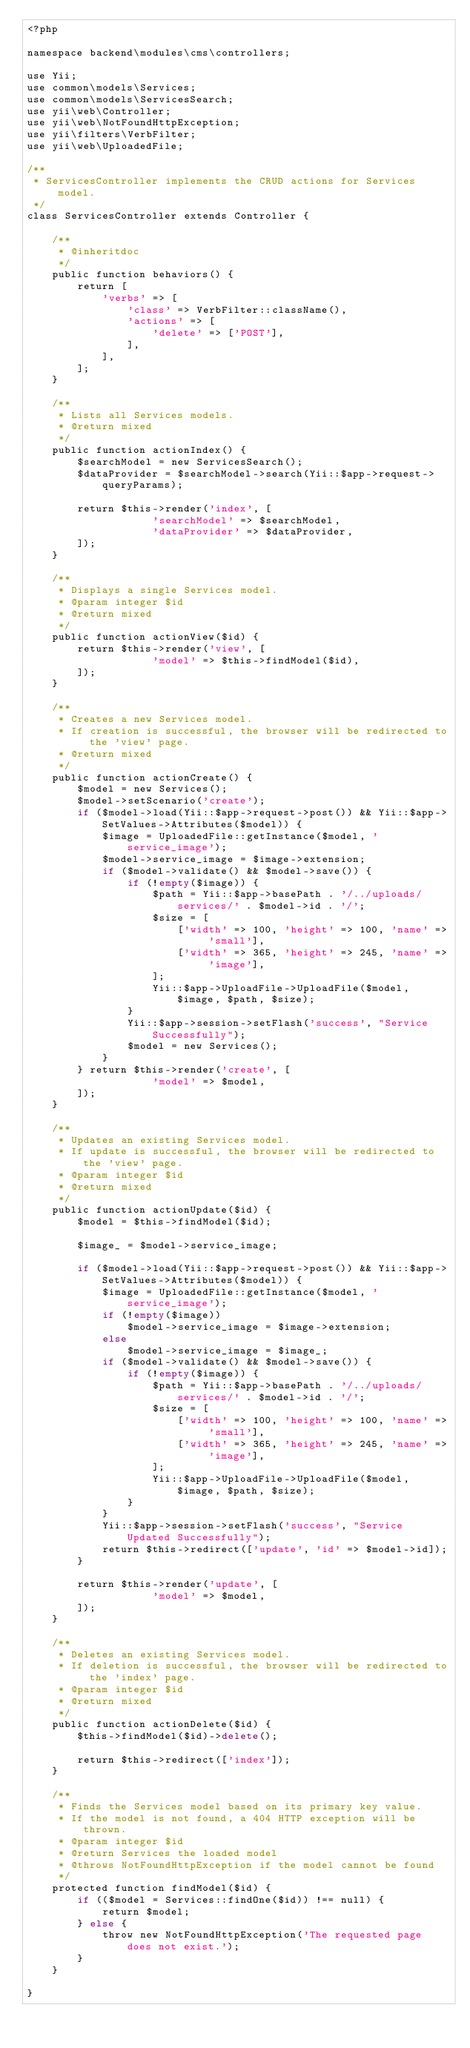Convert code to text. <code><loc_0><loc_0><loc_500><loc_500><_PHP_><?php

namespace backend\modules\cms\controllers;

use Yii;
use common\models\Services;
use common\models\ServicesSearch;
use yii\web\Controller;
use yii\web\NotFoundHttpException;
use yii\filters\VerbFilter;
use yii\web\UploadedFile;

/**
 * ServicesController implements the CRUD actions for Services model.
 */
class ServicesController extends Controller {

    /**
     * @inheritdoc
     */
    public function behaviors() {
        return [
            'verbs' => [
                'class' => VerbFilter::className(),
                'actions' => [
                    'delete' => ['POST'],
                ],
            ],
        ];
    }

    /**
     * Lists all Services models.
     * @return mixed
     */
    public function actionIndex() {
        $searchModel = new ServicesSearch();
        $dataProvider = $searchModel->search(Yii::$app->request->queryParams);

        return $this->render('index', [
                    'searchModel' => $searchModel,
                    'dataProvider' => $dataProvider,
        ]);
    }

    /**
     * Displays a single Services model.
     * @param integer $id
     * @return mixed
     */
    public function actionView($id) {
        return $this->render('view', [
                    'model' => $this->findModel($id),
        ]);
    }

    /**
     * Creates a new Services model.
     * If creation is successful, the browser will be redirected to the 'view' page.
     * @return mixed
     */
    public function actionCreate() {
        $model = new Services();
        $model->setScenario('create');
        if ($model->load(Yii::$app->request->post()) && Yii::$app->SetValues->Attributes($model)) {
            $image = UploadedFile::getInstance($model, 'service_image');
            $model->service_image = $image->extension;
            if ($model->validate() && $model->save()) {
                if (!empty($image)) {
                    $path = Yii::$app->basePath . '/../uploads/services/' . $model->id . '/';
                    $size = [
                        ['width' => 100, 'height' => 100, 'name' => 'small'],
                        ['width' => 365, 'height' => 245, 'name' => 'image'],
                    ];
                    Yii::$app->UploadFile->UploadFile($model, $image, $path, $size);
                }
                Yii::$app->session->setFlash('success', "Service Successfully");
                $model = new Services();
            }
        } return $this->render('create', [
                    'model' => $model,
        ]);
    }

    /**
     * Updates an existing Services model.
     * If update is successful, the browser will be redirected to the 'view' page.
     * @param integer $id
     * @return mixed
     */
    public function actionUpdate($id) {
        $model = $this->findModel($id);

        $image_ = $model->service_image;

        if ($model->load(Yii::$app->request->post()) && Yii::$app->SetValues->Attributes($model)) {
            $image = UploadedFile::getInstance($model, 'service_image');
            if (!empty($image))
                $model->service_image = $image->extension;
            else
                $model->service_image = $image_;
            if ($model->validate() && $model->save()) {
                if (!empty($image)) {
                    $path = Yii::$app->basePath . '/../uploads/services/' . $model->id . '/';
                    $size = [
                        ['width' => 100, 'height' => 100, 'name' => 'small'],
                        ['width' => 365, 'height' => 245, 'name' => 'image'],
                    ];
                    Yii::$app->UploadFile->UploadFile($model, $image, $path, $size);
                }
            }
            Yii::$app->session->setFlash('success', "Service Updated Successfully");
            return $this->redirect(['update', 'id' => $model->id]);
        }

        return $this->render('update', [
                    'model' => $model,
        ]);
    }

    /**
     * Deletes an existing Services model.
     * If deletion is successful, the browser will be redirected to the 'index' page.
     * @param integer $id
     * @return mixed
     */
    public function actionDelete($id) {
        $this->findModel($id)->delete();

        return $this->redirect(['index']);
    }

    /**
     * Finds the Services model based on its primary key value.
     * If the model is not found, a 404 HTTP exception will be thrown.
     * @param integer $id
     * @return Services the loaded model
     * @throws NotFoundHttpException if the model cannot be found
     */
    protected function findModel($id) {
        if (($model = Services::findOne($id)) !== null) {
            return $model;
        } else {
            throw new NotFoundHttpException('The requested page does not exist.');
        }
    }

}
</code> 